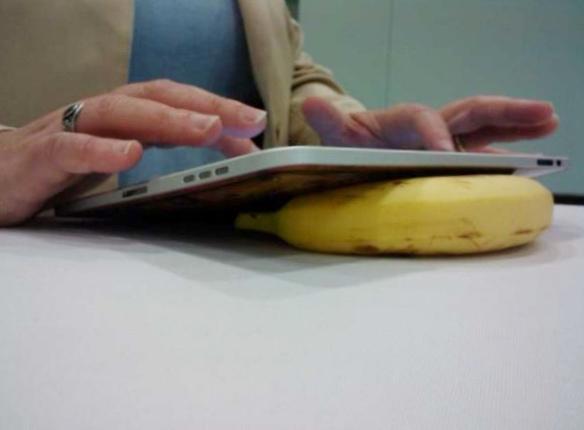What is the tablet laying on?
Write a very short answer. Banana. What type of jewelry is the person wearing?
Answer briefly. Ring. What is on the person's finger?
Give a very brief answer. Ring. What fruit is in the hands?
Be succinct. Banana. 